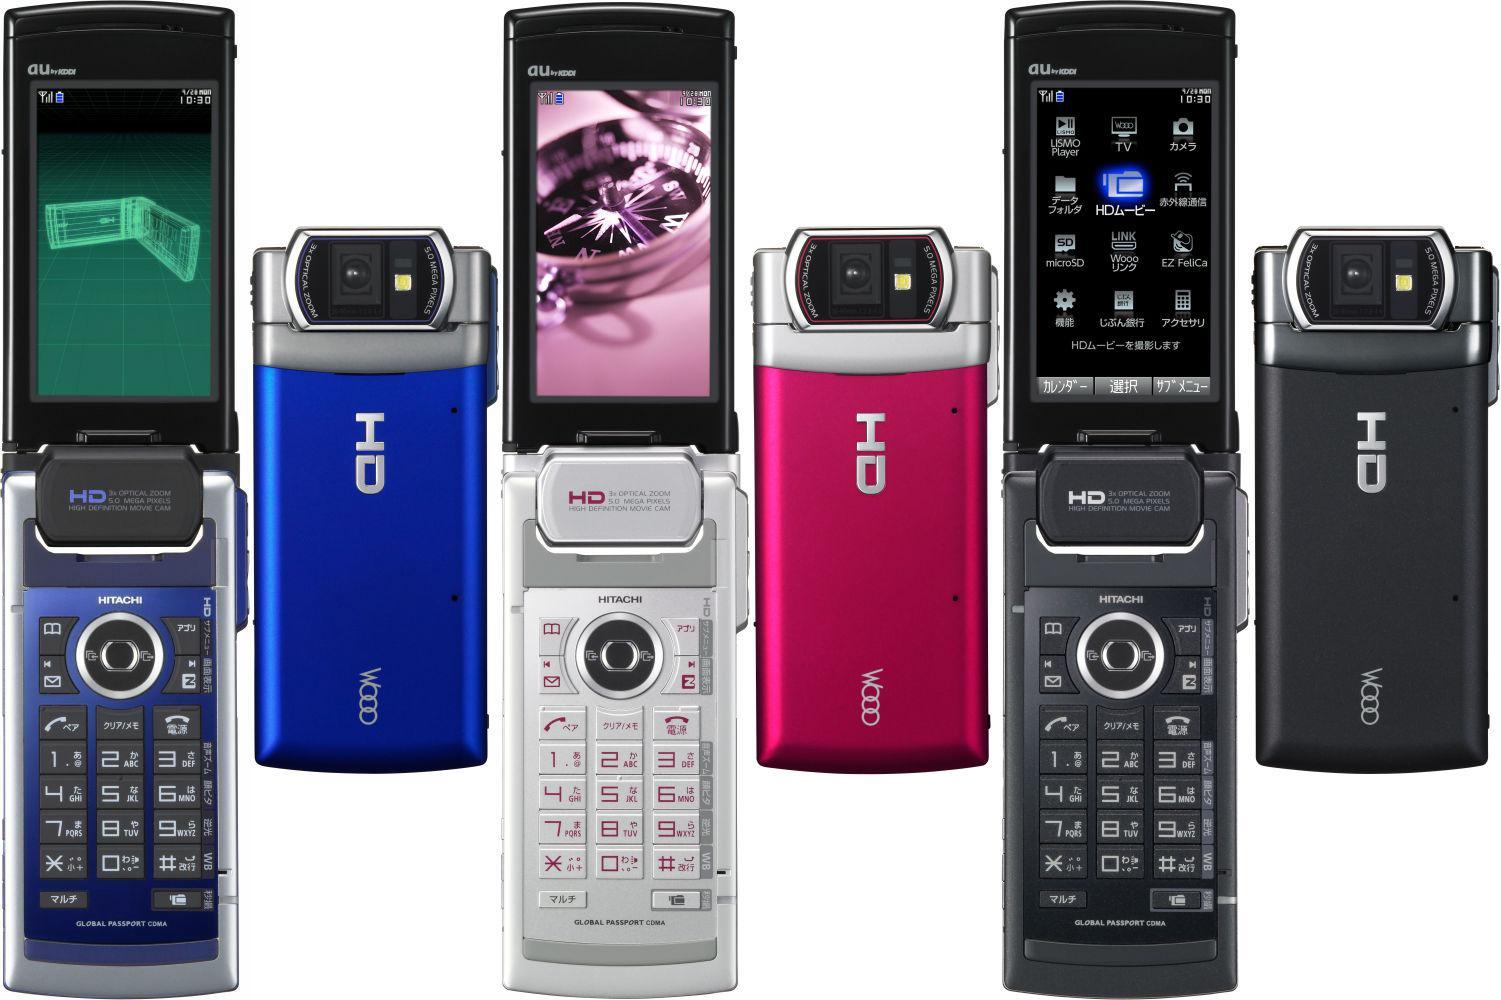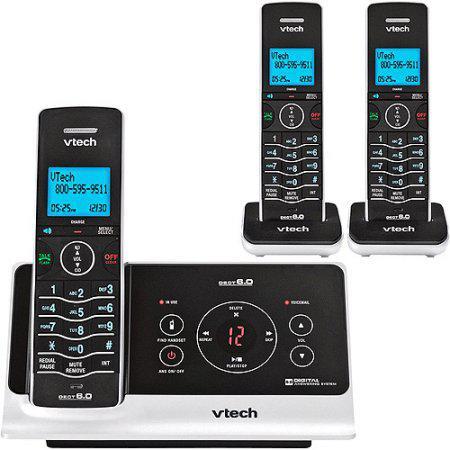The first image is the image on the left, the second image is the image on the right. Considering the images on both sides, is "There are four phones with at least one red phone." valid? Answer yes or no. No. The first image is the image on the left, the second image is the image on the right. For the images shown, is this caption "Each image includes at least three 'extra' handsets resting in their bases and at least one main handset on a larger base." true? Answer yes or no. No. 